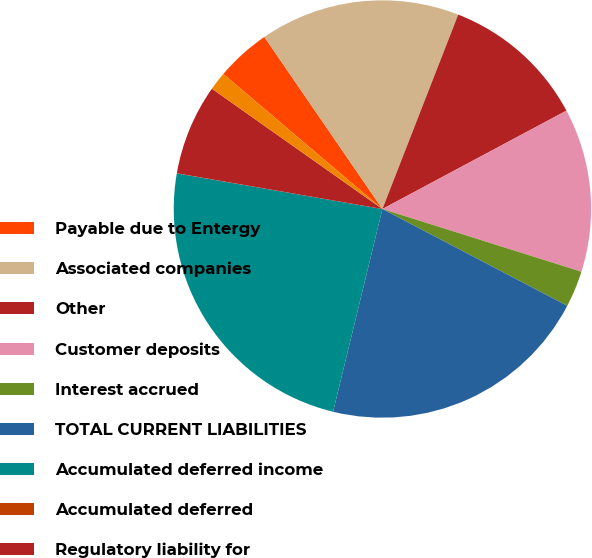<chart> <loc_0><loc_0><loc_500><loc_500><pie_chart><fcel>Payable due to Entergy<fcel>Associated companies<fcel>Other<fcel>Customer deposits<fcel>Interest accrued<fcel>TOTAL CURRENT LIABILITIES<fcel>Accumulated deferred income<fcel>Accumulated deferred<fcel>Regulatory liability for<fcel>Asset retirement cost<nl><fcel>4.23%<fcel>15.49%<fcel>11.27%<fcel>12.67%<fcel>2.82%<fcel>21.12%<fcel>23.93%<fcel>0.01%<fcel>7.04%<fcel>1.42%<nl></chart> 